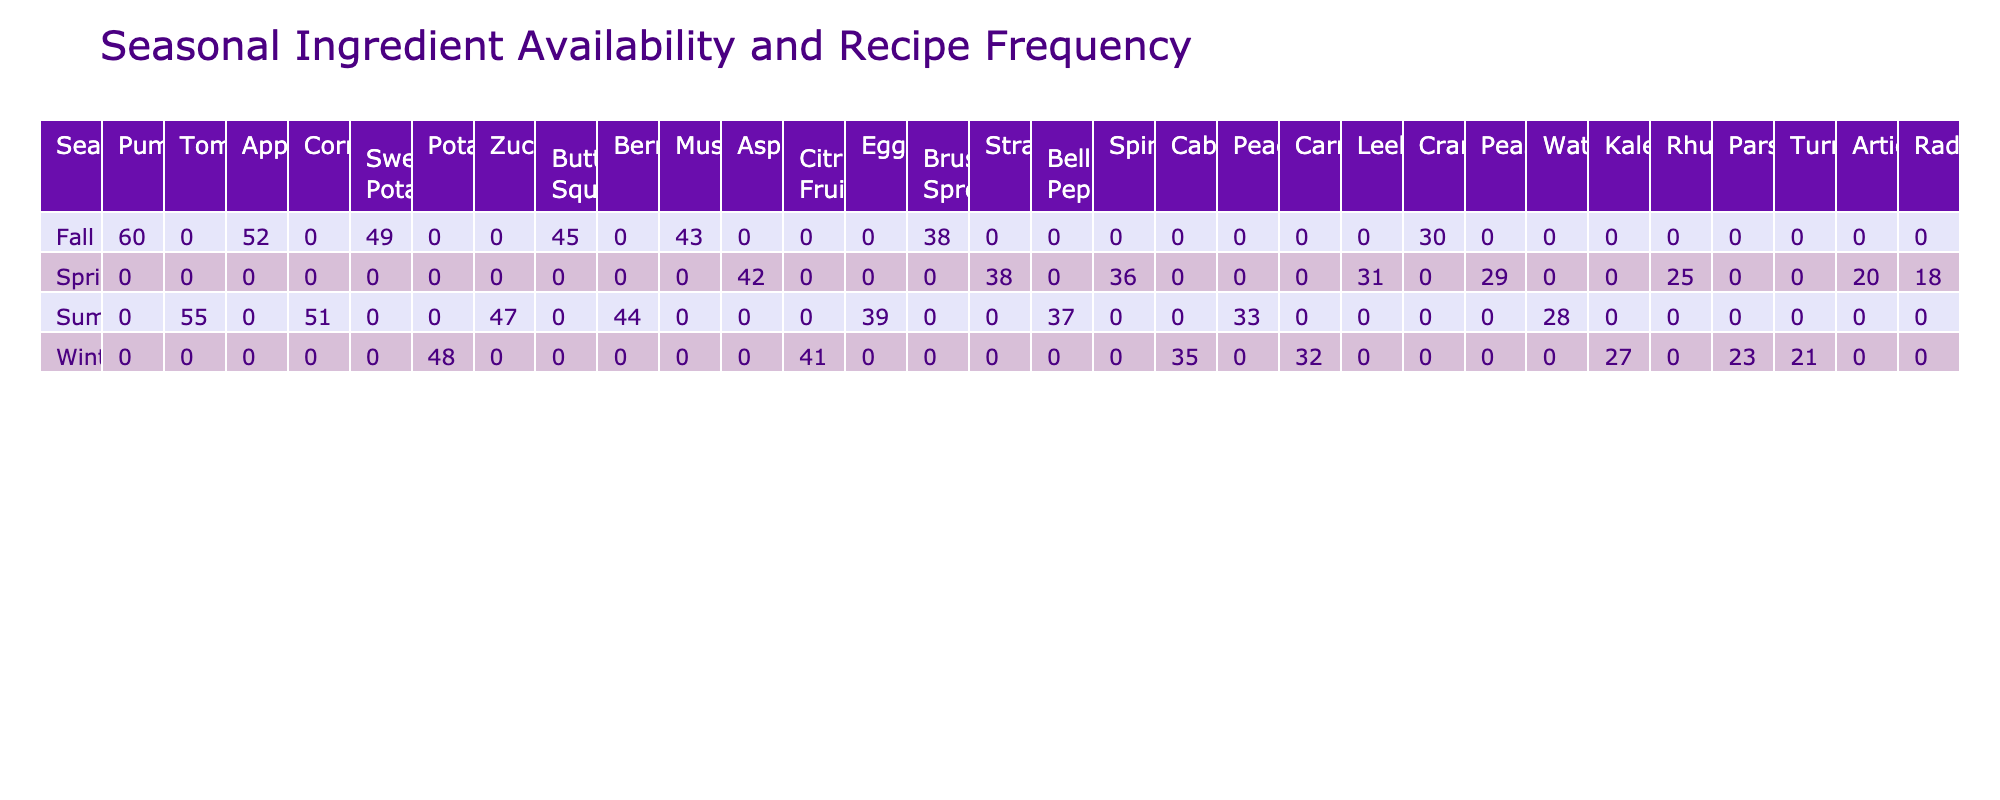What is the most frequent recipe in the Fall season? The Fall season's most frequent recipe is Pumpkin Spice Latte, with a frequency of 60, as seen directly in the table.
Answer: 60 Which ingredient has the highest recipe frequency overall? The ingredient with the highest frequency is Tomatoes, appearing in Caprese Salad with a frequency of 55. This is determined by summing frequencies across all seasons and finding the highest.
Answer: 55 How many recipes feature strawberries, and what is their total frequency? There is one recipe featuring strawberries, which is Strawberry Shortcake, with a total frequency of 38. This is seen by checking the row associated with strawberries in the Spring season.
Answer: 38 What is the total frequency of recipes using squash (Butternut Squash and Sweet Potatoes)? The total frequency for Butternut Squash Soup (45) and Sweet Potato Fries (49) is 45 + 49 = 94. This requires summing the frequencies of specified recipes from the Fall section.
Answer: 94 Is there a recipe for Brussels Sprouts in Spring? No, there is not a recipe for Brussels Sprouts listed in the Spring season; it only appears in Fall. This can be confirmed by checking the Spring column for any listed recipe.
Answer: No What is the average frequency of recipes in Winter? The Winter season includes five recipes: Loaded Baked Potatoes (48), Cabbage Rolls (35), Orange Chicken (41), Honey Glazed Carrots (32), and Kale Chips (27). Summing these gives 48 + 35 + 41 + 32 + 27 = 183. To find the average, divide by the number of recipes: 183 / 5 = 36.6.
Answer: 36.6 Which season has the least total recipe frequency when combined? By calculating the total frequencies: Spring (229), Summer (258), Fall (274), and Winter (203), we find that Winter has the lowest total frequency of 203. This requires adding up all recipe frequencies for each season and comparing totals.
Answer: Winter Is there a recipe that features both apples and cranberries? No, there are no recipes that feature both apples and cranberries together. Apples are found in Apple Crisp, while cranberries are in Cranberry Sauce, confirming no overlap based on the table information.
Answer: No 